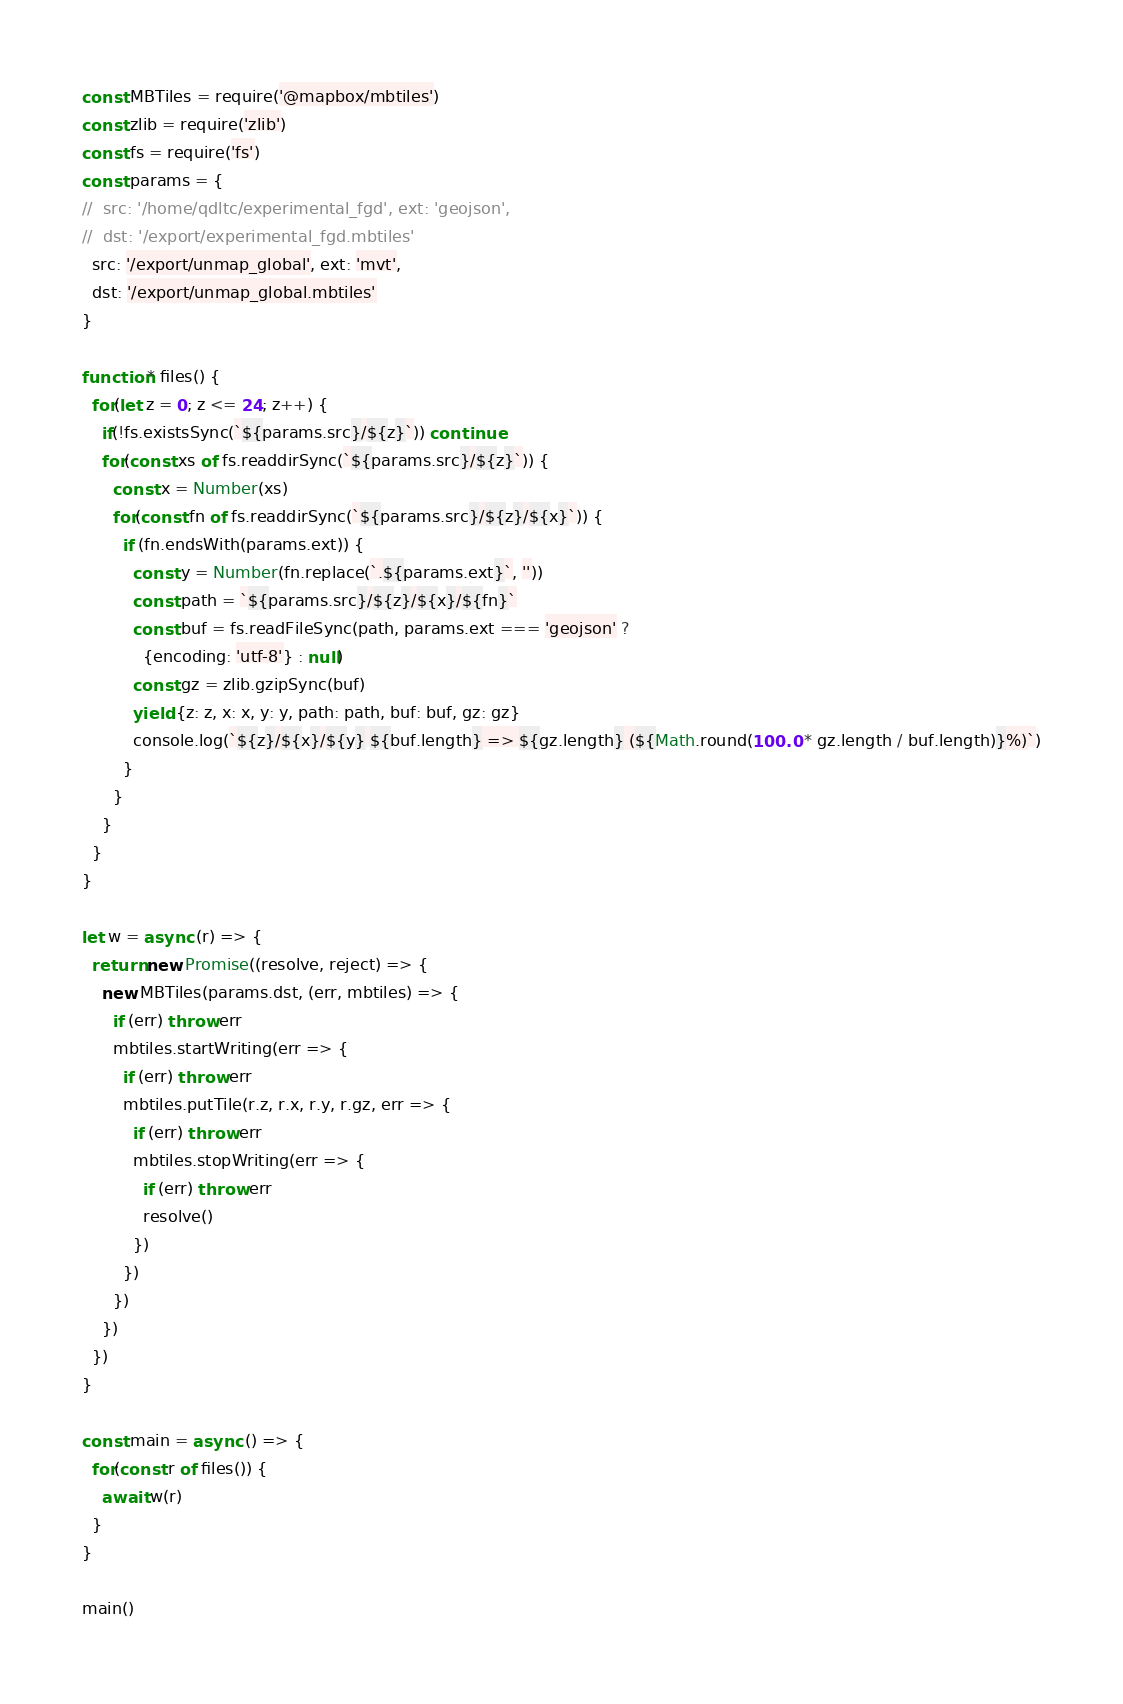<code> <loc_0><loc_0><loc_500><loc_500><_JavaScript_>const MBTiles = require('@mapbox/mbtiles')
const zlib = require('zlib')
const fs = require('fs')
const params = {
//  src: '/home/qdltc/experimental_fgd', ext: 'geojson',
//  dst: '/export/experimental_fgd.mbtiles'
  src: '/export/unmap_global', ext: 'mvt',
  dst: '/export/unmap_global.mbtiles'
}

function* files() {
  for(let z = 0; z <= 24; z++) {
    if(!fs.existsSync(`${params.src}/${z}`)) continue
    for(const xs of fs.readdirSync(`${params.src}/${z}`)) {
      const x = Number(xs)
      for(const fn of fs.readdirSync(`${params.src}/${z}/${x}`)) {
        if (fn.endsWith(params.ext)) {
          const y = Number(fn.replace(`.${params.ext}`, ''))
          const path = `${params.src}/${z}/${x}/${fn}`
          const buf = fs.readFileSync(path, params.ext === 'geojson' ? 
            {encoding: 'utf-8'} : null)
          const gz = zlib.gzipSync(buf)
          yield {z: z, x: x, y: y, path: path, buf: buf, gz: gz}
          console.log(`${z}/${x}/${y} ${buf.length} => ${gz.length} (${Math.round(100.0 * gz.length / buf.length)}%)`)
        }
      }
    }
  }
}

let w = async (r) => {
  return new Promise((resolve, reject) => {
    new MBTiles(params.dst, (err, mbtiles) => {
      if (err) throw err
      mbtiles.startWriting(err => {
        if (err) throw err
        mbtiles.putTile(r.z, r.x, r.y, r.gz, err => {
          if (err) throw err
          mbtiles.stopWriting(err => {
            if (err) throw err
            resolve()
          })
        })
      })
    })
  })
}

const main = async () => {
  for(const r of files()) {
    await w(r)
  }
}

main()
</code> 